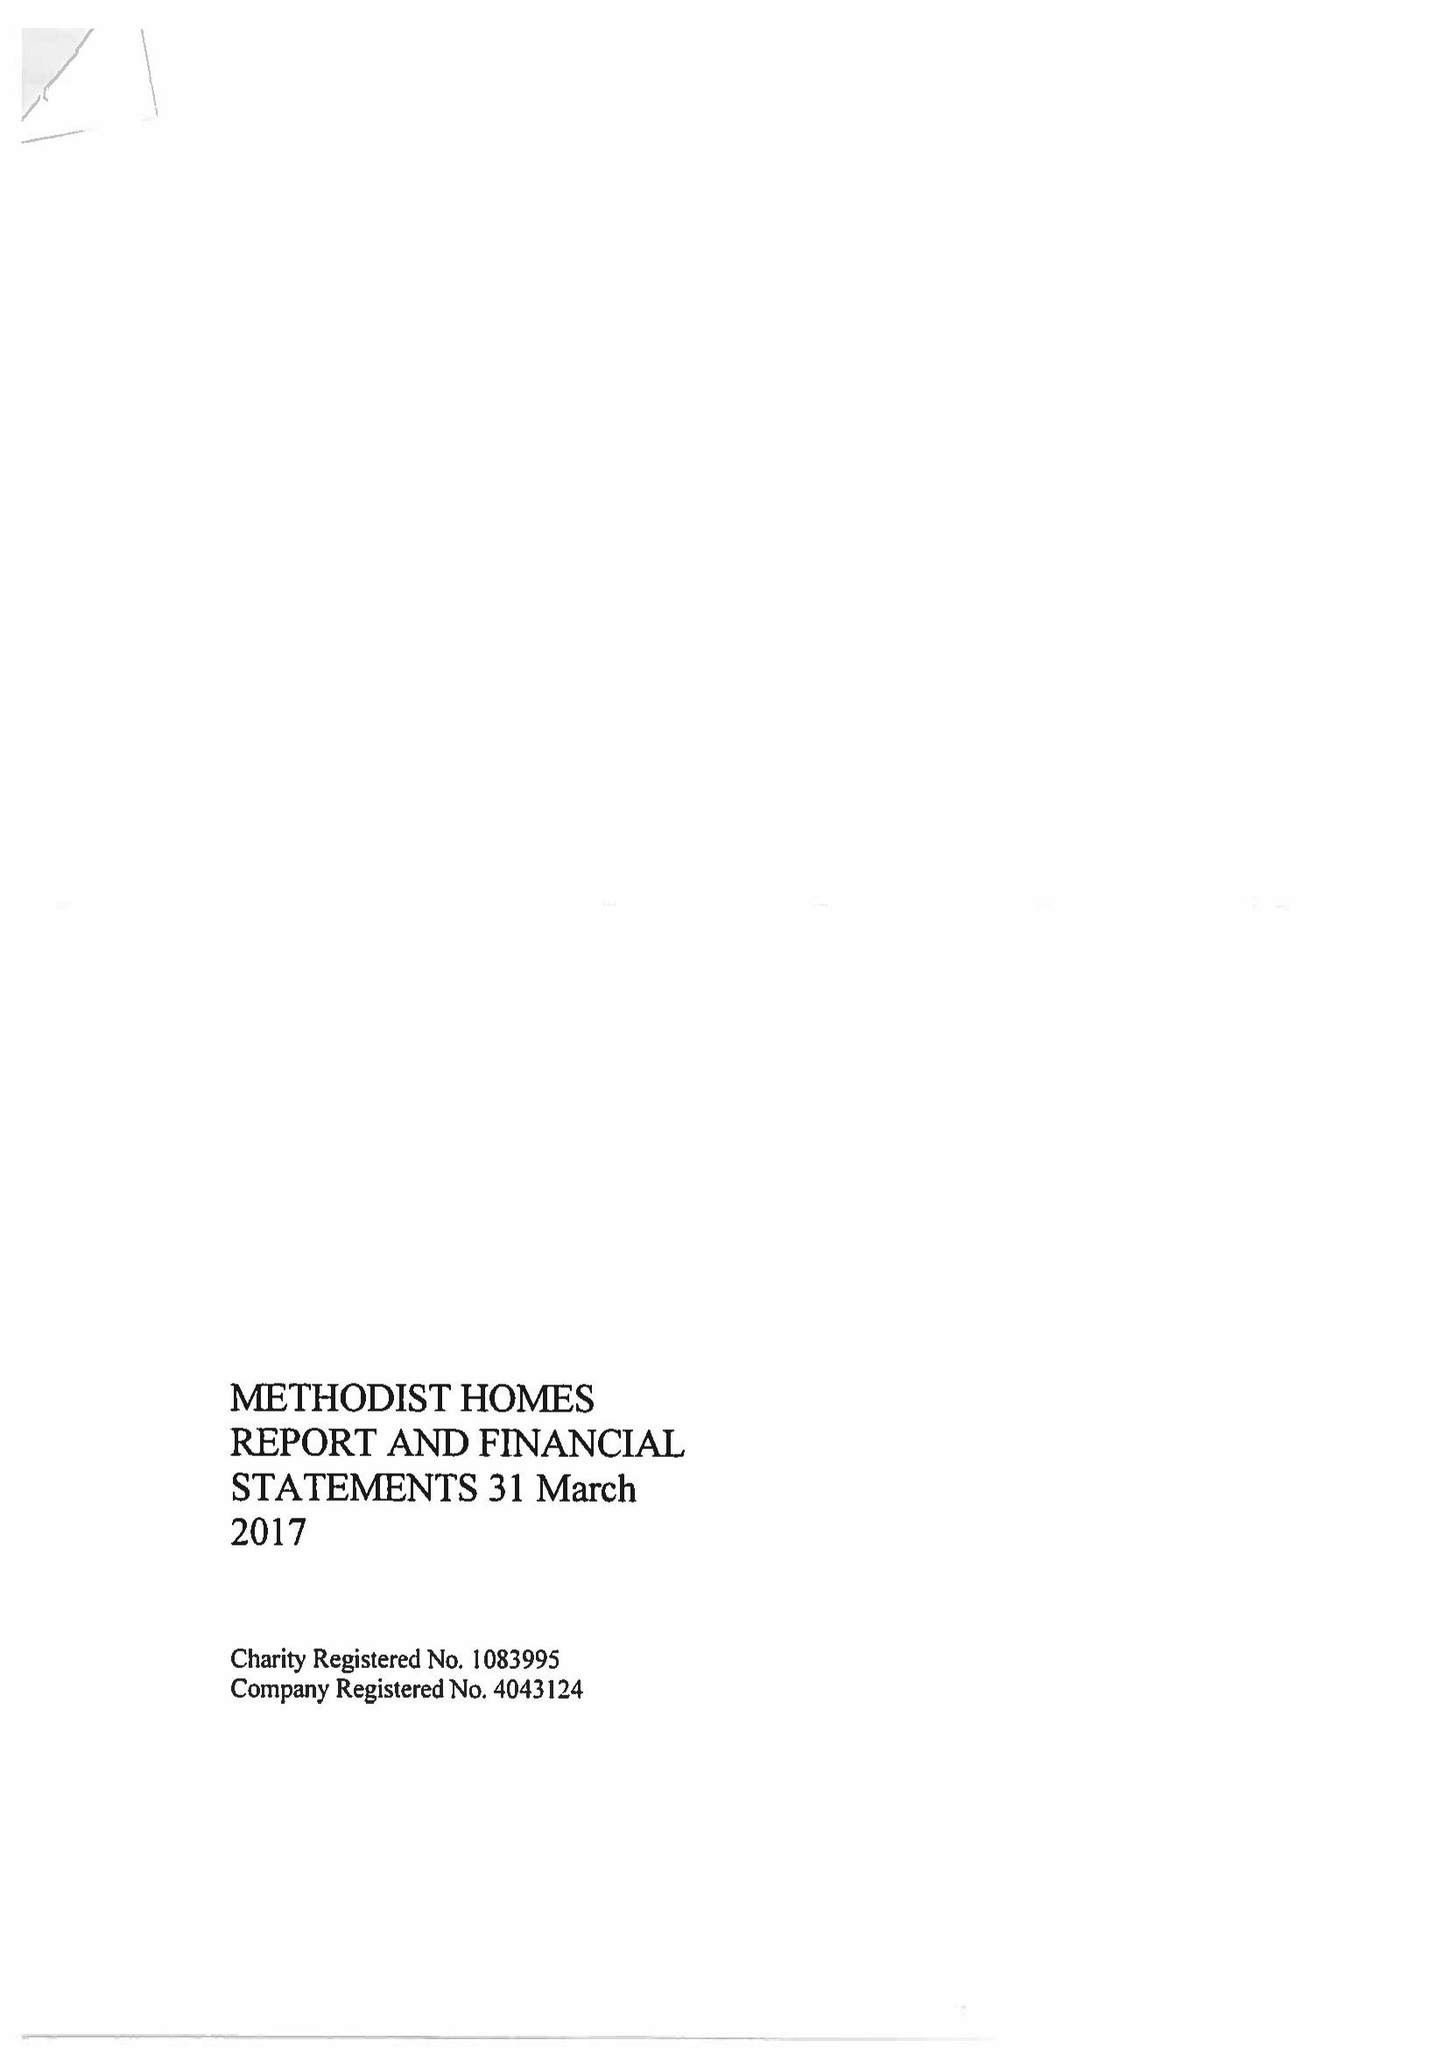What is the value for the spending_annually_in_british_pounds?
Answer the question using a single word or phrase. 194808000.00 